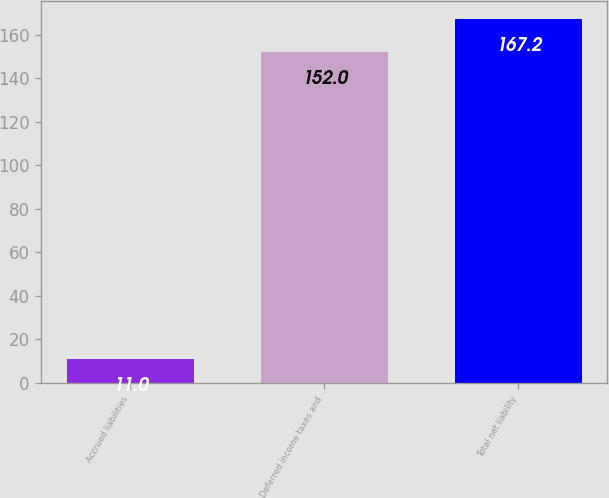<chart> <loc_0><loc_0><loc_500><loc_500><bar_chart><fcel>Accrued liabilities<fcel>Deferred income taxes and<fcel>Total net liability<nl><fcel>11<fcel>152<fcel>167.2<nl></chart> 